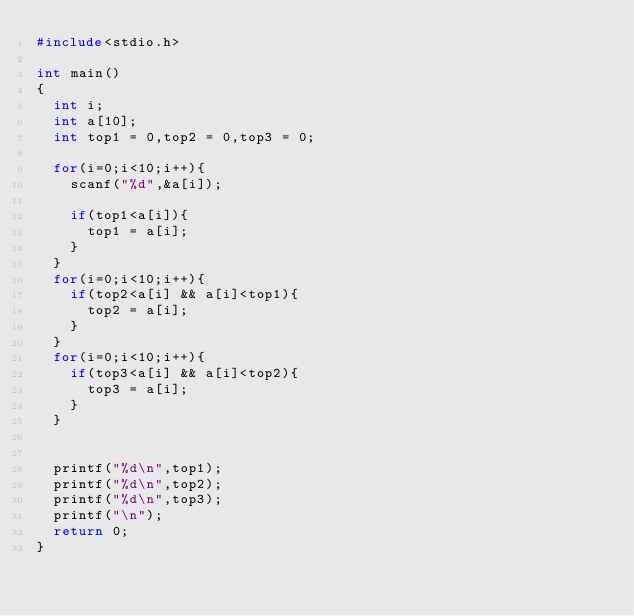<code> <loc_0><loc_0><loc_500><loc_500><_C_>#include<stdio.h>

int main()
{
  int i;
  int a[10];
  int top1 = 0,top2 = 0,top3 = 0;

  for(i=0;i<10;i++){
    scanf("%d",&a[i]);

    if(top1<a[i]){
      top1 = a[i];
    }
  }
  for(i=0;i<10;i++){
    if(top2<a[i] && a[i]<top1){
      top2 = a[i];
    }
  }
  for(i=0;i<10;i++){
    if(top3<a[i] && a[i]<top2){
      top3 = a[i];
    }
  }


  printf("%d\n",top1);
  printf("%d\n",top2);
  printf("%d\n",top3);
  printf("\n");
  return 0;
}</code> 